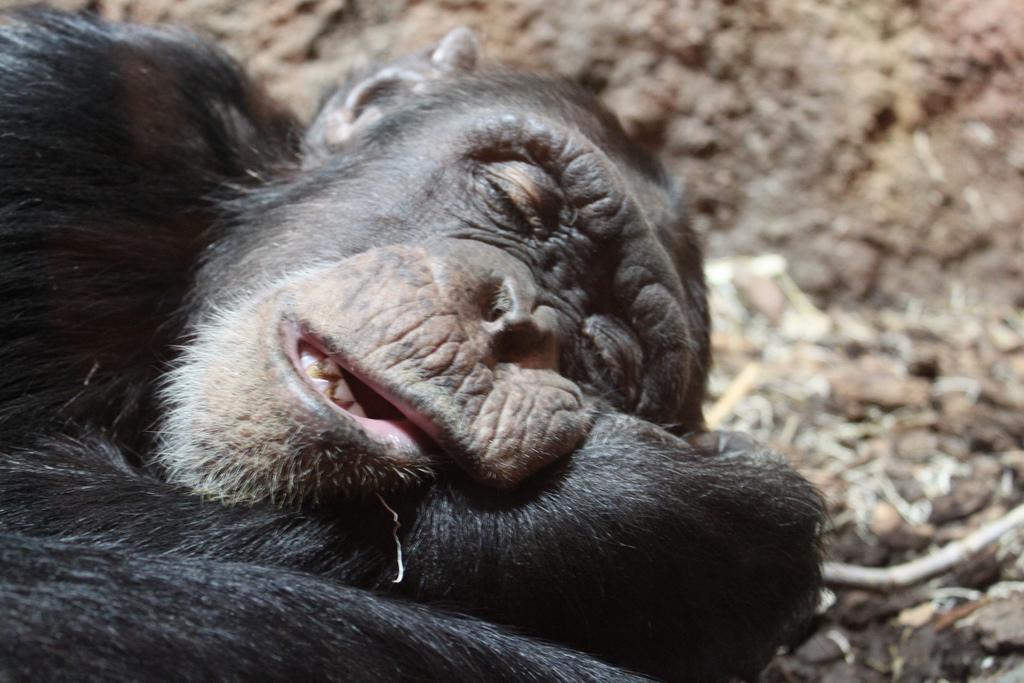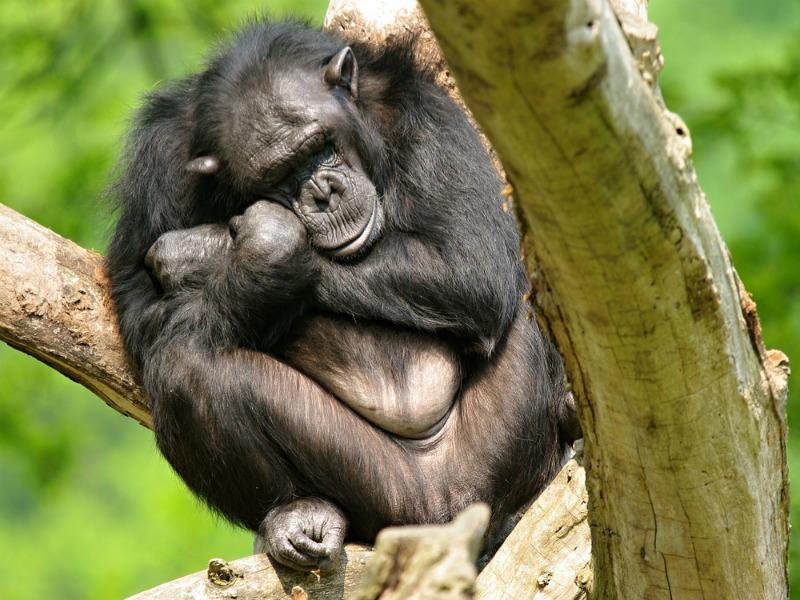The first image is the image on the left, the second image is the image on the right. Given the left and right images, does the statement "An image shows a baby chimp sleeping on top of an adult chimp." hold true? Answer yes or no. No. The first image is the image on the left, the second image is the image on the right. Given the left and right images, does the statement "One animal is sleeping on another in the image on the left." hold true? Answer yes or no. No. 